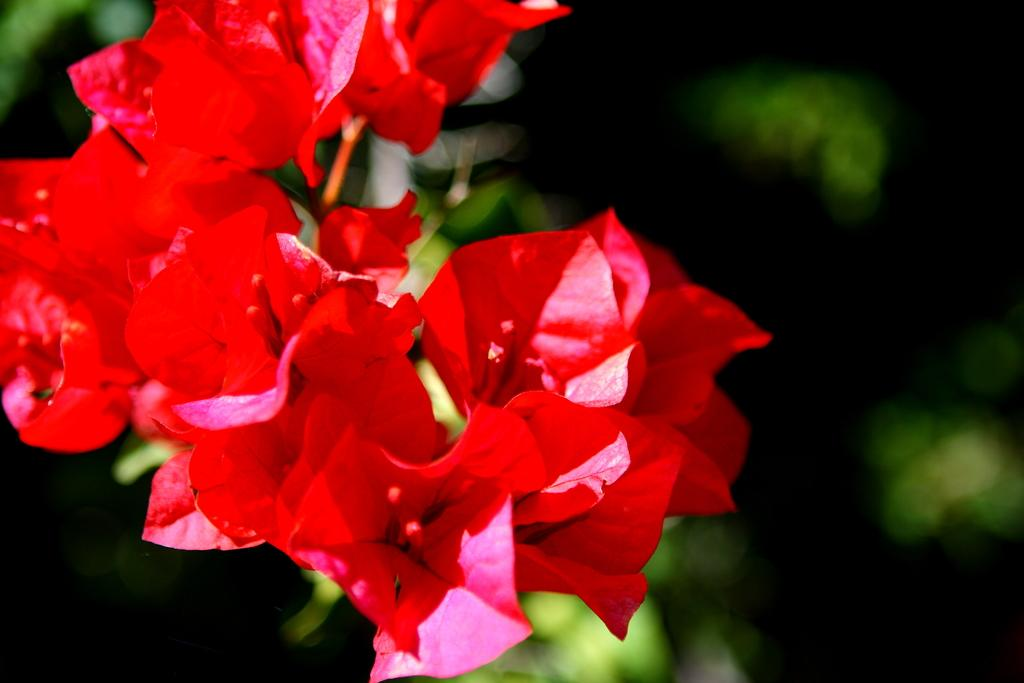What is present in the image? There are flowers in the image. Can you describe the background of the image? The background of the image is blurred. How does the faucet control the flow of rice in the image? There is no faucet or rice present in the image; it only features flowers with a blurred background. 